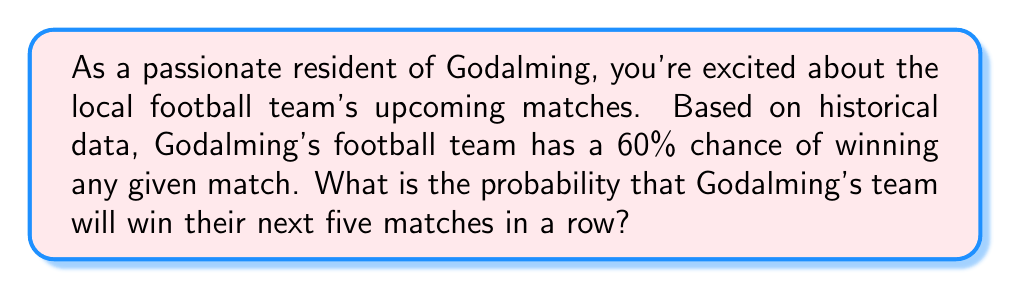Can you solve this math problem? To solve this problem, we need to use the concept of independent events and multiplication of probabilities.

1. Each match is considered an independent event, as the outcome of one match doesn't affect the others.

2. The probability of winning a single match is 60% or 0.60.

3. To find the probability of winning all five matches in a row, we need to multiply the individual probabilities:

   $$ P(\text{5 wins in a row}) = 0.60 \times 0.60 \times 0.60 \times 0.60 \times 0.60 $$

4. This can be written as:

   $$ P(\text{5 wins in a row}) = (0.60)^5 $$

5. Calculate the result:

   $$ (0.60)^5 = 0.07776 $$

6. Convert to a percentage:

   $$ 0.07776 \times 100\% = 7.776\% $$

Therefore, the probability of Godalming's football team winning their next five matches in a row is approximately 7.78%.
Answer: The probability is $0.07776$ or $7.78\%$. 